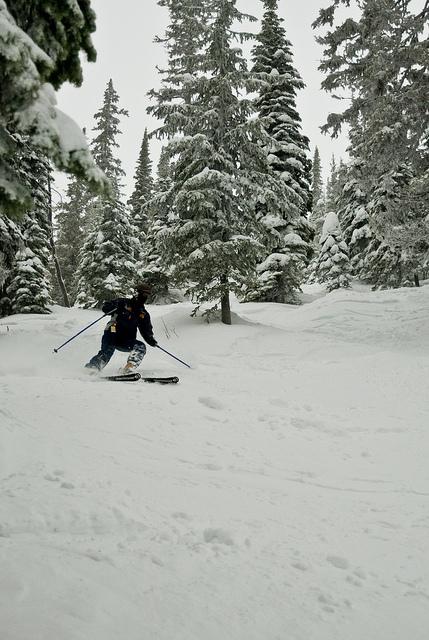In what season of the year was this photo most likely taken?
Short answer required. Winter. Is there someone watching the skier?
Give a very brief answer. No. Is it currently snowing?
Quick response, please. No. Is the man traveling at a fast speed?
Be succinct. Yes. What is the person doing?
Quick response, please. Skiing. Which position is the skier in first place as of this gate?
Quick response, please. First. 